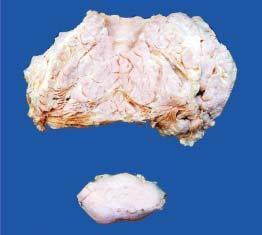what is the main mass multilobulated with?
Answer the question using a single word or phrase. Increased fat while lower part of the image shows a separate encapsulated gelatinous mass 